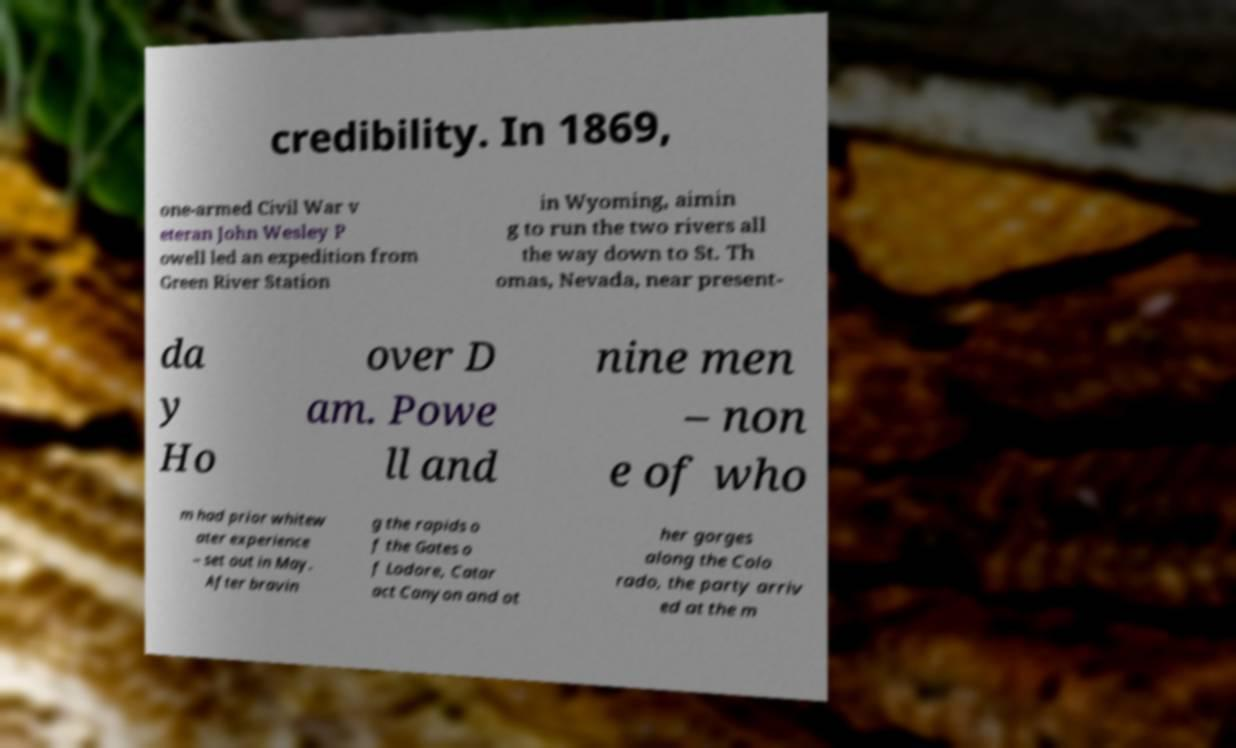Could you extract and type out the text from this image? credibility. In 1869, one-armed Civil War v eteran John Wesley P owell led an expedition from Green River Station in Wyoming, aimin g to run the two rivers all the way down to St. Th omas, Nevada, near present- da y Ho over D am. Powe ll and nine men – non e of who m had prior whitew ater experience – set out in May. After bravin g the rapids o f the Gates o f Lodore, Catar act Canyon and ot her gorges along the Colo rado, the party arriv ed at the m 